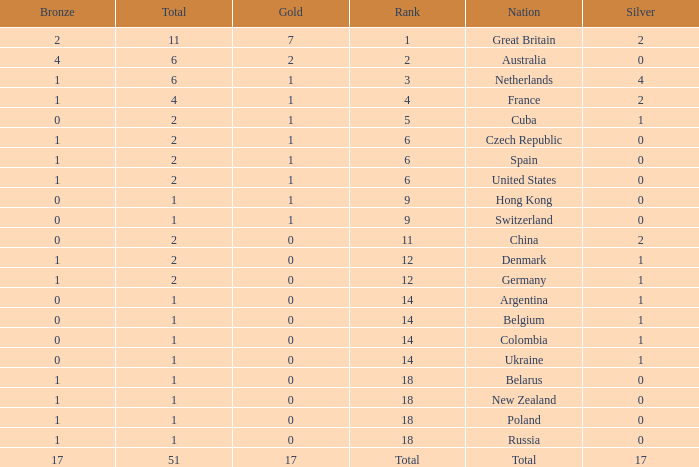Tell me the rank for bronze less than 17 and gold less than 1 11.0. 